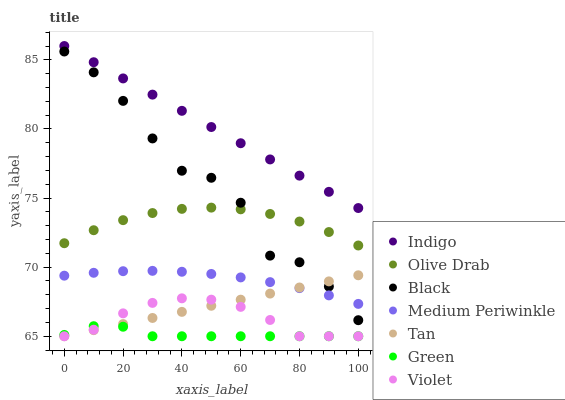Does Green have the minimum area under the curve?
Answer yes or no. Yes. Does Indigo have the maximum area under the curve?
Answer yes or no. Yes. Does Medium Periwinkle have the minimum area under the curve?
Answer yes or no. No. Does Medium Periwinkle have the maximum area under the curve?
Answer yes or no. No. Is Tan the smoothest?
Answer yes or no. Yes. Is Black the roughest?
Answer yes or no. Yes. Is Medium Periwinkle the smoothest?
Answer yes or no. No. Is Medium Periwinkle the roughest?
Answer yes or no. No. Does Violet have the lowest value?
Answer yes or no. Yes. Does Medium Periwinkle have the lowest value?
Answer yes or no. No. Does Indigo have the highest value?
Answer yes or no. Yes. Does Medium Periwinkle have the highest value?
Answer yes or no. No. Is Green less than Medium Periwinkle?
Answer yes or no. Yes. Is Olive Drab greater than Violet?
Answer yes or no. Yes. Does Black intersect Tan?
Answer yes or no. Yes. Is Black less than Tan?
Answer yes or no. No. Is Black greater than Tan?
Answer yes or no. No. Does Green intersect Medium Periwinkle?
Answer yes or no. No. 